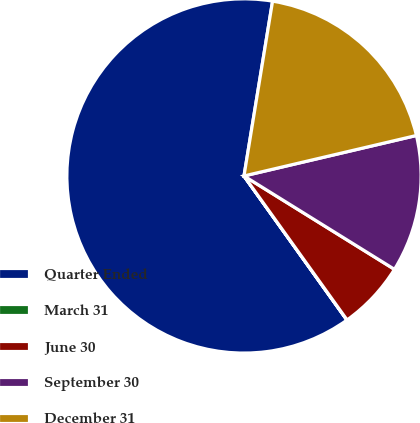Convert chart to OTSL. <chart><loc_0><loc_0><loc_500><loc_500><pie_chart><fcel>Quarter Ended<fcel>March 31<fcel>June 30<fcel>September 30<fcel>December 31<nl><fcel>62.45%<fcel>0.02%<fcel>6.27%<fcel>12.51%<fcel>18.75%<nl></chart> 